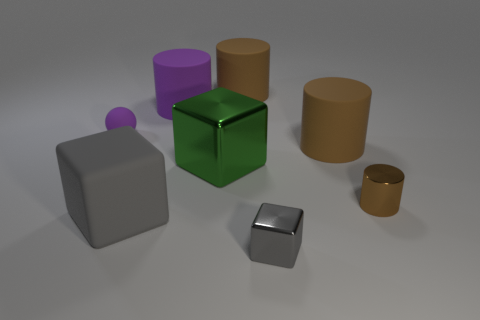Subtract all yellow balls. How many brown cylinders are left? 3 Subtract 1 cylinders. How many cylinders are left? 3 Subtract all yellow cylinders. Subtract all yellow spheres. How many cylinders are left? 4 Add 1 large purple matte cylinders. How many objects exist? 9 Subtract all blocks. How many objects are left? 5 Subtract all small purple spheres. Subtract all rubber blocks. How many objects are left? 6 Add 2 tiny shiny blocks. How many tiny shiny blocks are left? 3 Add 1 tiny gray things. How many tiny gray things exist? 2 Subtract 1 purple cylinders. How many objects are left? 7 